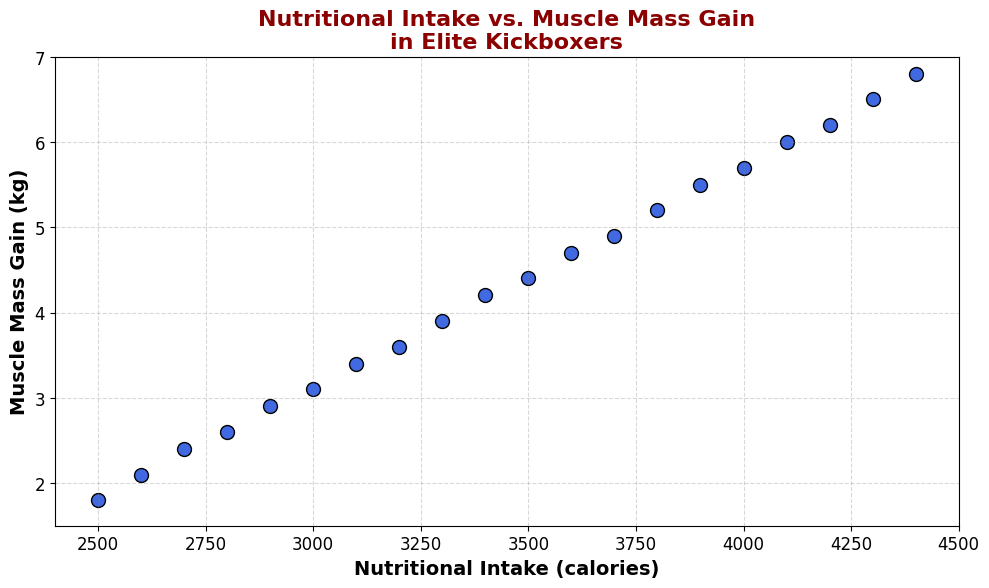How does muscle mass gain change as nutritional intake increases? Observing the scatter plot, as the nutritional intake increases from 2500 to 4400 calories, muscle mass gain also increases progressively.
Answer: Both variables increase together What is the muscle mass gain for a nutritional intake of 3500 calories? Locate the data point corresponding to 3500 calories on the x-axis and check the muscle mass gain on the y-axis.
Answer: 4.4 kg Which data point has the highest muscle mass gain, and what is the corresponding nutritional intake? Identify the highest point on the y-axis, then check the corresponding x-axis value.
Answer: 6.8 kg at 4400 calories Compare the muscle mass gain for nutritional intakes of 3000 and 4000 calories. Find the data points for 3000 and 4000 calories on the x-axis, and compare their respective y-axis values.
Answer: 3.1 kg at 3000 calories, 5.7 kg at 4000 calories What is the average muscle mass gain for nutritional intakes of 2800, 3200, and 3600 calories? Locate the muscle mass gains for 2800, 3200, and 3600 calories, sum them, and divide by 3. Gains: 2.6, 3.6, 4.7. Calculate (2.6 + 3.6 + 4.7) / 3.
Answer: 3.63 kg Is there a positive correlation between nutritional intake and muscle mass gain? Observe the overall trend of the points; they move upward and to the right, indicating that as one increases, so does the other.
Answer: Yes What is the range of muscle mass gain observed in the plot? Identify the minimum and maximum values on the y-axis for muscle mass gain. The min is 1.8 kg, the max is 6.8 kg. Range is 6.8 - 1.8.
Answer: 5.0 kg Does the scatter plot suggest a linear relationship between nutritional intake and muscle mass gain? The data points form a straight line-like pattern, suggesting a linear relationship.
Answer: Yes What is the difference in muscle mass gain between the data points at 2900 and 3300 calories? Locate the muscle mass gain for 2900 (2.9 kg) and 3300 (3.9 kg); subtract the former from the latter.
Answer: 1.0 kg How many data points are there on the scatter plot? Count the number of distinct markers plotted.
Answer: 20 